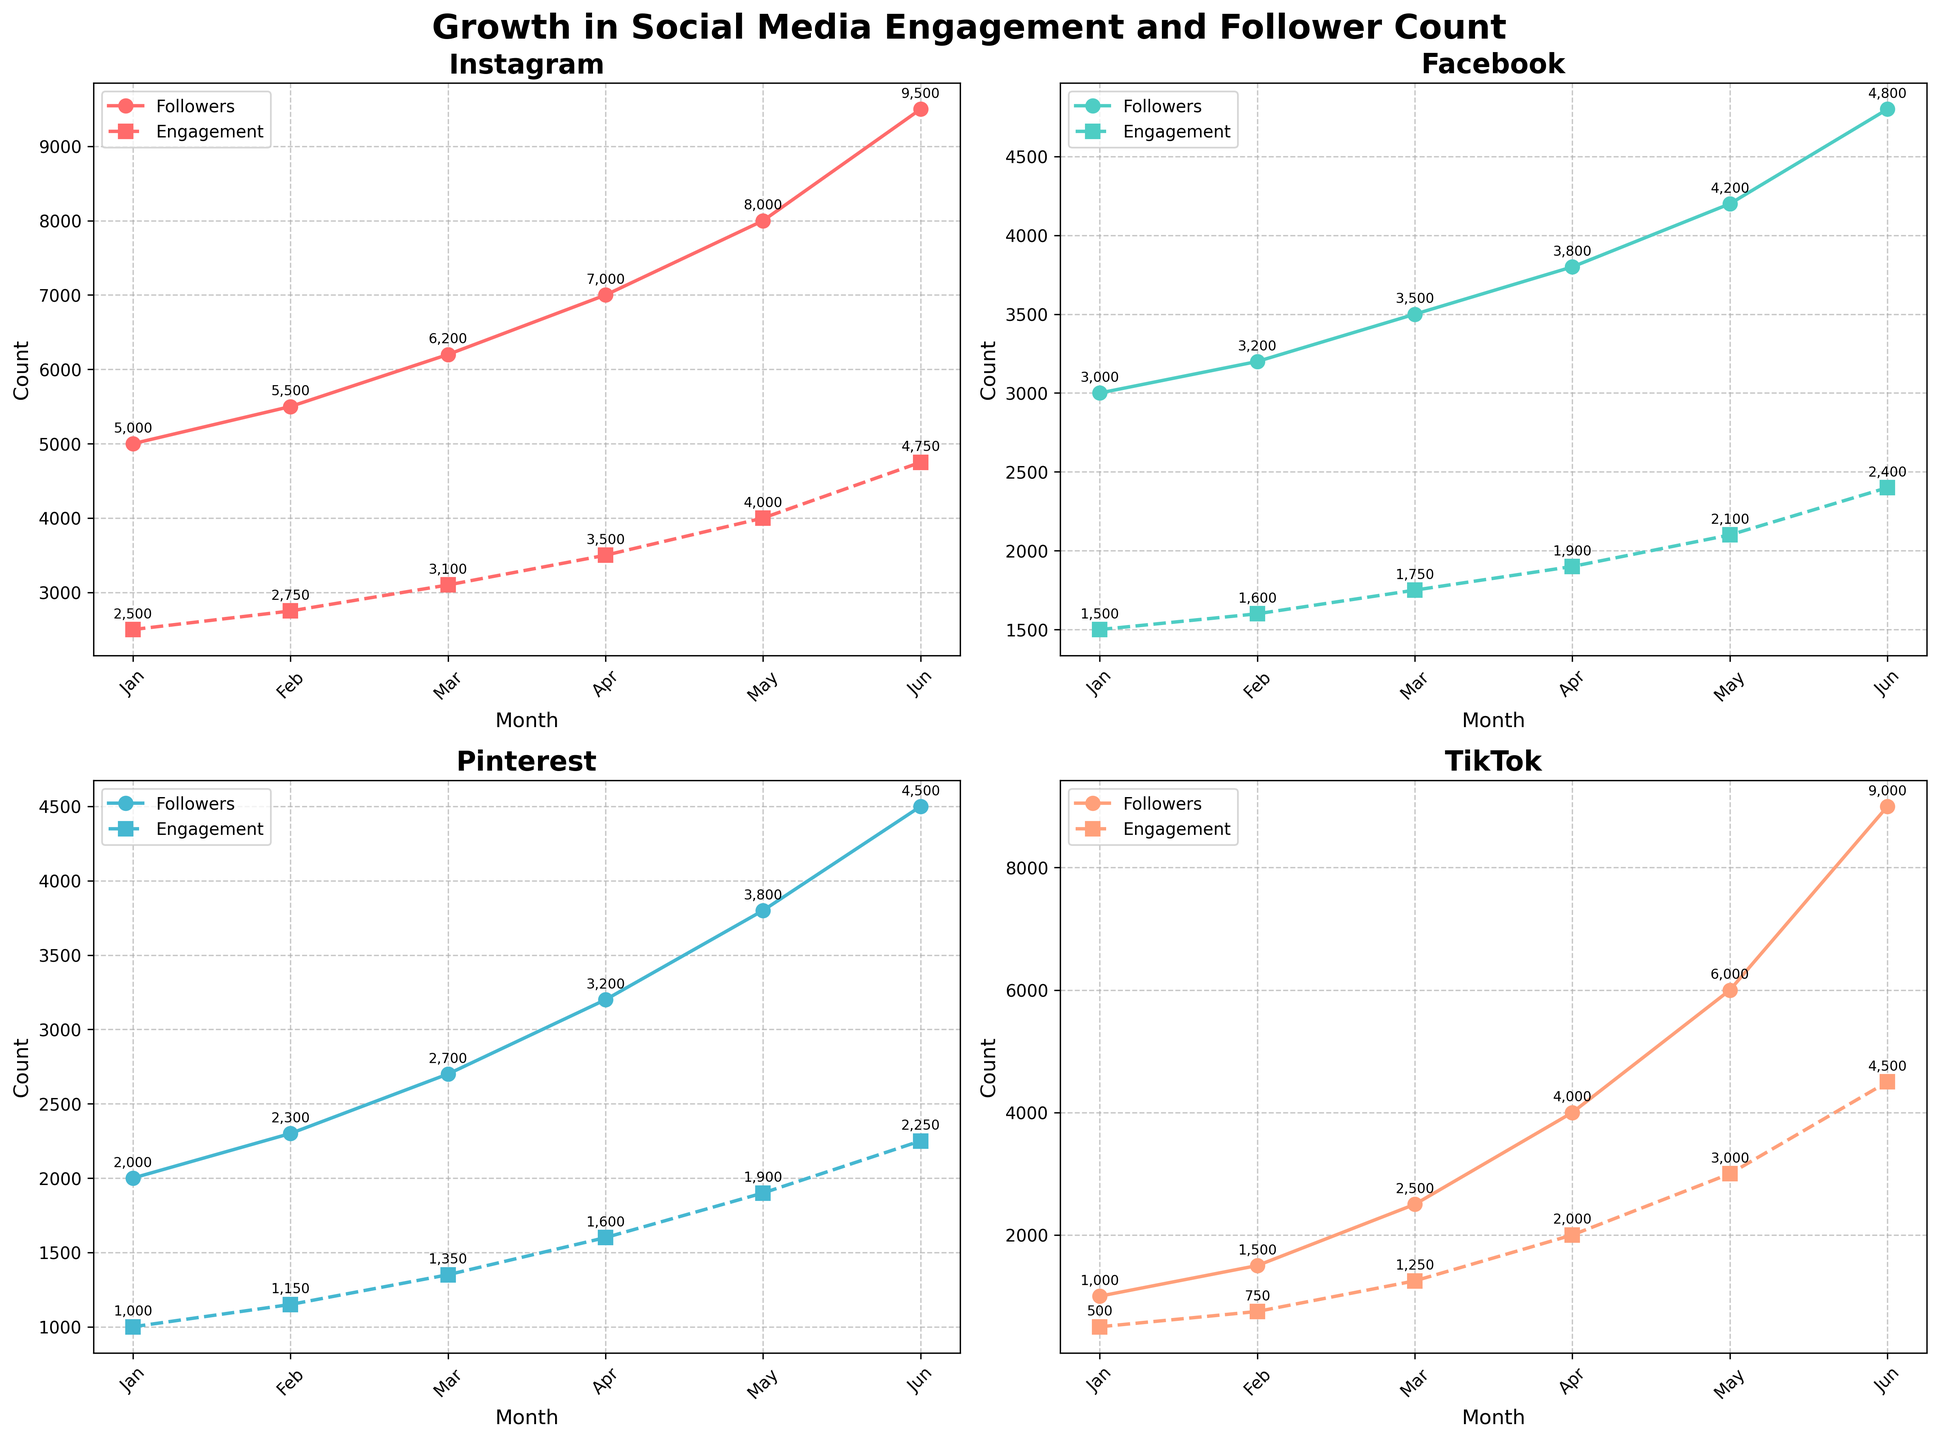Which platform had the highest follower count in June? Look at the June data points for each subplot and compare. Instagram has 9500, Facebook has 4800, Pinterest has 4500, and TikTok has 9000 followers. Instagram has the highest follower count.
Answer: Instagram Which platform had the fastest growth in engagement from January to June? Calculate the difference between June and January engagement values for each platform: Instagram (4750-2500 = 2250), Facebook (2400-1500 = 900), Pinterest (2250-1000 = 1250), TikTok (4500-500 = 4000). TikTok had the fastest growth.
Answer: TikTok How many more followers did Pinterest gain compared to Facebook from May to June? Subtract May follower counts from June counts for both platforms and then compare: Pinterest (4500-3800 = 700), Facebook (4800-4200 = 600). Pinterest gained 100 more followers.
Answer: 100 Which platform showed the least fluctuation in their engagement numbers? Observe the steepness and consistency of the engagement lines in each subplot. Facebook's line is the least steep and most consistent.
Answer: Facebook On which platform did follower and engagement counts converge the most closely in any month? Compare the follower and engagement count lines for each month across all platforms. In April, TikTok's follower (4000) and engagement (2000) counts are the closest.
Answer: TikTok in April What was the average follower count for TikTok over the six months? Sum TikTok's follower counts (1000 + 1500 + 2500 + 4000 + 6000 + 9000 = 24000) and divide by six months. The average follower count is 24000/6 = 4000.
Answer: 4000 Which platform experienced the highest increase in followers from April to May? Observe the shift in the follower count lines from April to May for each platform: Instagram (8000-7000 = 1000), Facebook (4200-3800 = 400), Pinterest (3800-3200 = 600), TikTok (6000-4000 = 2000). TikTok had the highest increase.
Answer: TikTok For which platform is the visual difference between the engagement and follower counts the smallest? Look at the width of the gap between the engagement and follower lines for each platform. Facebook shows the smallest visual difference.
Answer: Facebook 